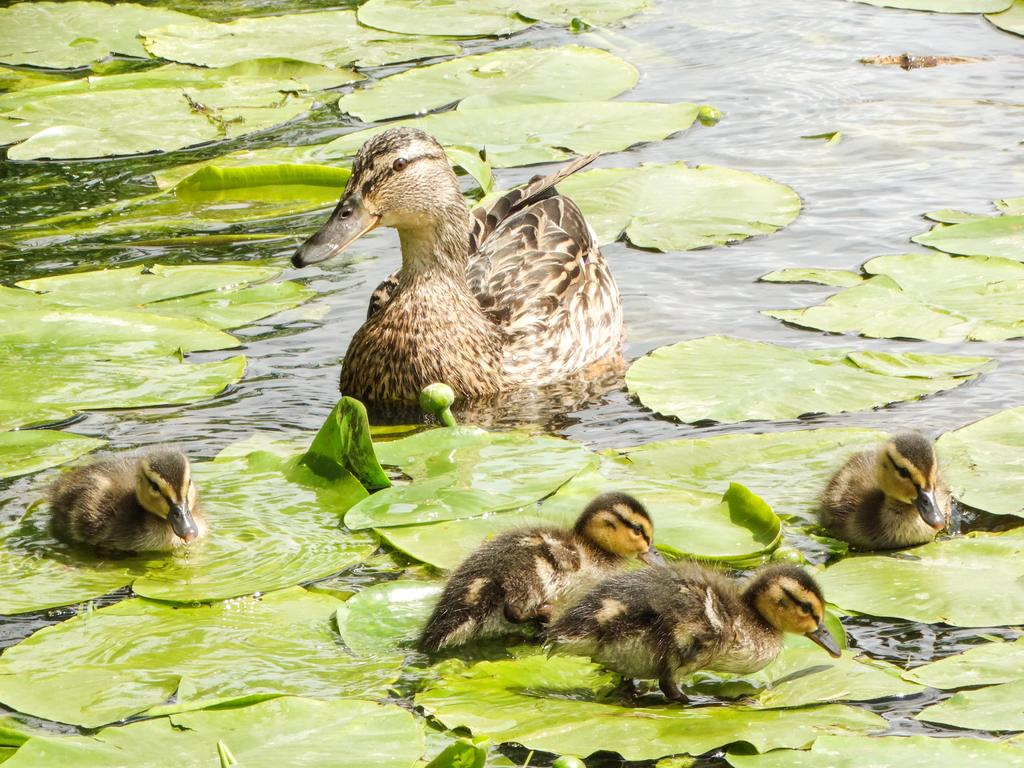What body of water is present in the image? There is a lake in the image. What animals can be seen in the water? There is a duck with four ducklings in the water. What type of vegetation is visible in the image? There are leaves visible in the image. What is the small, unopened flower in the water called? There is a bud in the water. What shape is the glass that the duck is drinking from in the image? There is no glass present in the image; the duck is in the water, not drinking from a glass. 